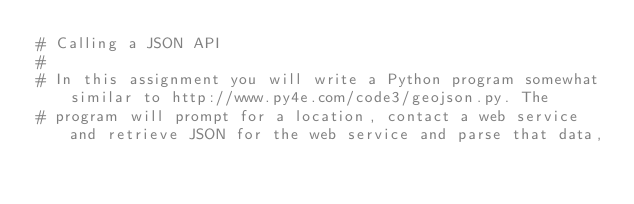Convert code to text. <code><loc_0><loc_0><loc_500><loc_500><_Python_># Calling a JSON API
#
# In this assignment you will write a Python program somewhat similar to http://www.py4e.com/code3/geojson.py. The
# program will prompt for a location, contact a web service and retrieve JSON for the web service and parse that data,</code> 